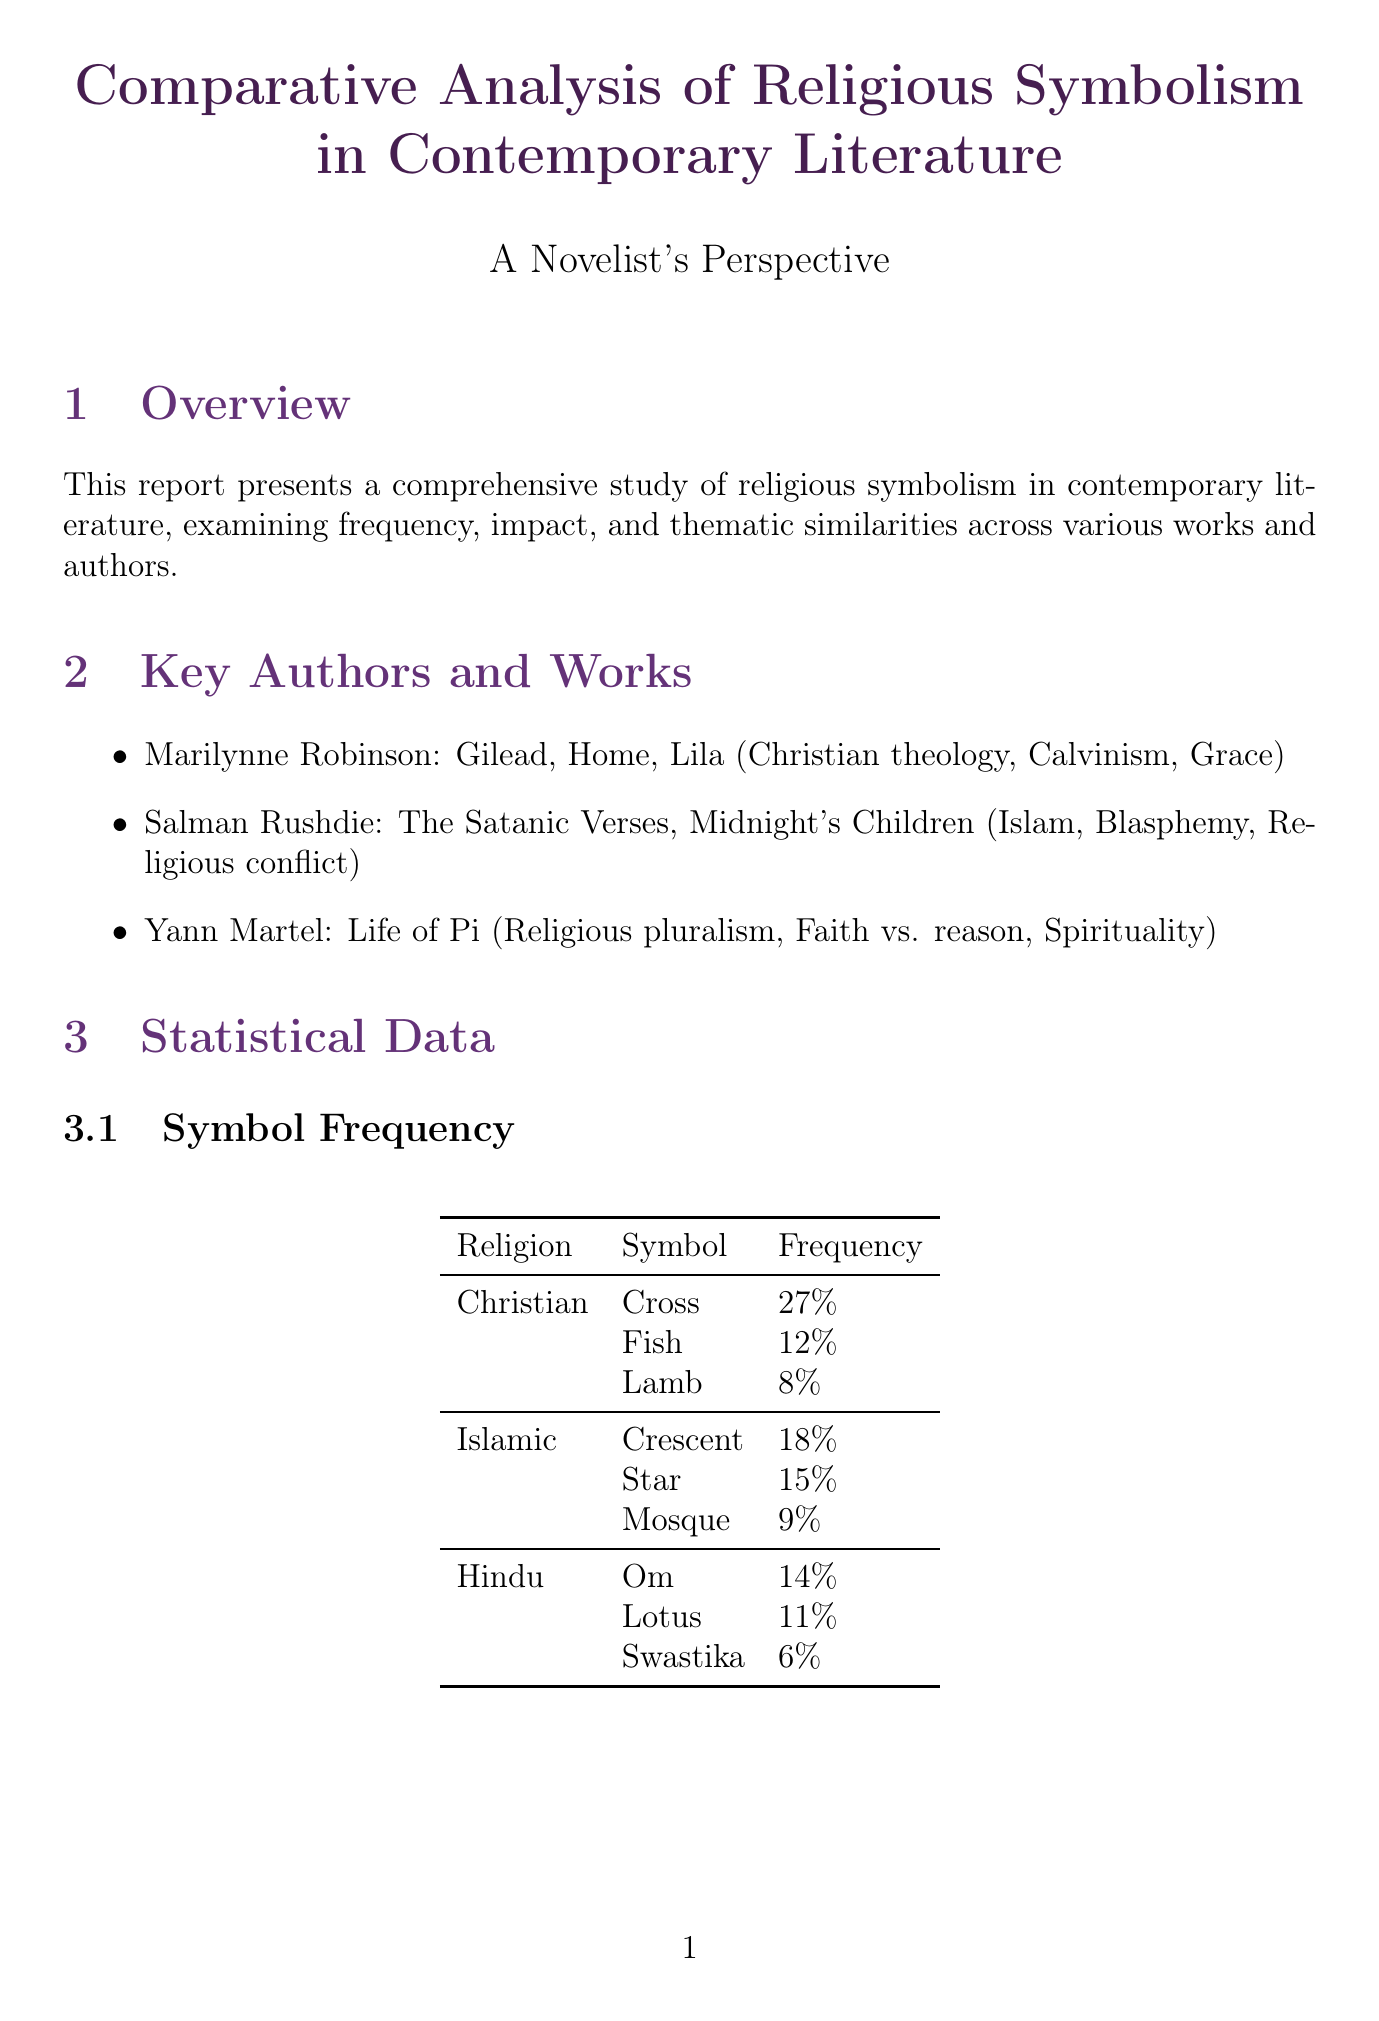What is the primary focus of the report? The report focuses on a comprehensive study of religious symbolism in contemporary literature.
Answer: Religious symbolism Who is the author of "Gilead"? The author of "Gilead" is Marilynne Robinson, who is listed under key authors and works.
Answer: Marilynne Robinson What percentage of readers report increased interest in religious themes? The document states that 73% of surveyed readers report increased interest in religious themes.
Answer: 73% Which religious symbol has the highest frequency among Christian symbols? The highest frequency Christian symbol mentioned in the document is the cross, at 27%.
Answer: Cross What are the two themes compared in the document? The themes compared include moral ambiguity and faith and doubt.
Answer: Moral ambiguity and faith and doubt What percentage of literary critics acknowledge the significance of religious symbolism? 85% of literary critics acknowledge the significance of religious symbolism in contemporary works.
Answer: 85% Which collaborative project focuses on shared moral themes? The collaborative project focusing on shared moral themes is the Interfaith Writing Workshop.
Answer: Interfaith Writing Workshop How many notable works are listed for Salman Rushdie? The document lists two notable works for Salman Rushdie: "The Satanic Verses" and "Midnight's Children."
Answer: Two What is the proposed research initiative mentioned in the collaborative opportunities? The proposed research initiative mentioned is "Symbolism in Fiction: A Data-Driven Approach."
Answer: Symbolism in Fiction: A Data-Driven Approach 